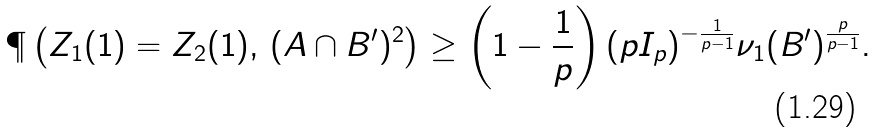<formula> <loc_0><loc_0><loc_500><loc_500>\P \left ( Z _ { 1 } ( 1 ) = Z _ { 2 } ( 1 ) , \, ( A \cap B ^ { \prime } ) ^ { 2 } \right ) \geq \left ( 1 - \frac { 1 } { p } \right ) ( p I _ { p } ) ^ { - \frac { 1 } { p - 1 } } \nu _ { 1 } ( B ^ { \prime } ) ^ { \frac { p } { p - 1 } } .</formula> 